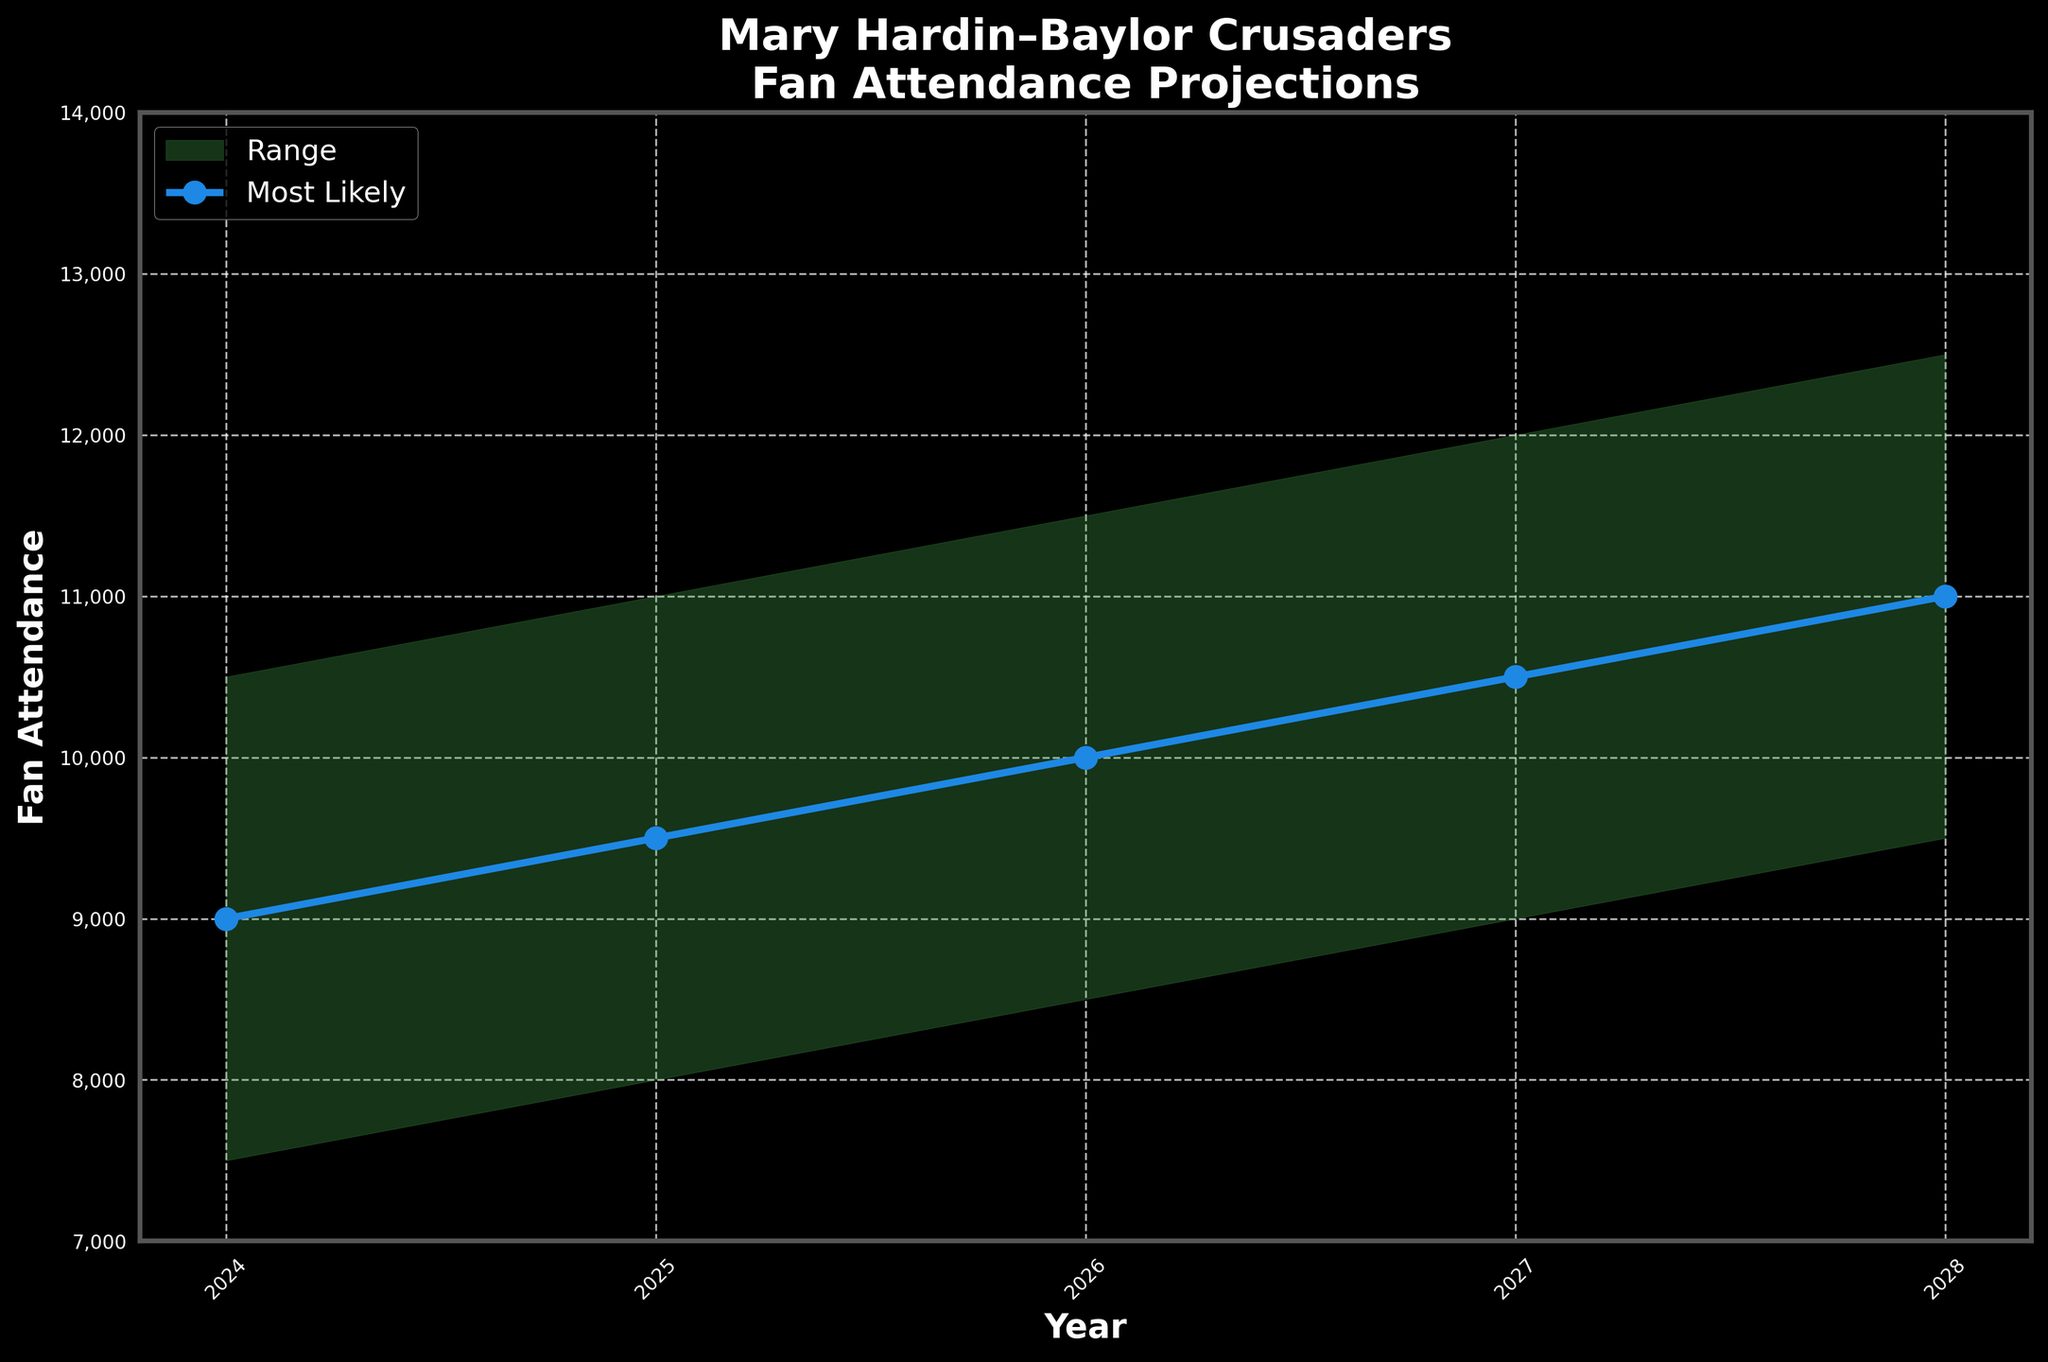What is the title of the figure? The title is prominently displayed at the top of the figure and serves as a summary of the information presented.
Answer: Mary Hardin–Baylor Crusaders Fan Attendance Projections How many years of projected fan attendance are shown in the chart? The x-axis lists all the years included in the projections. Counting them gives the total.
Answer: 5 years What is the highest projected attendance figure for the year 2025? Look at the "High" value for the year 2025 on the respective line on the chart.
Answer: 11,000 Which year has the lowest 'Most Likely' fan attendance value? Compare the 'Most Likely' values for all years.
Answer: 2024 What is the range of projected attendance for the year 2026? Subtract the 'Low' value for 2026 from the 'High' value for 2026. The difference gives the range.
Answer: 3,000 How much is the 'Most Likely' attendance projected to increase from 2024 to 2028? Subtract the 'Most Likely' value in 2024 from the 'Most Likely' value in 2028.
Answer: 2,000 In which year is the projected 'High' fan attendance first expected to reach 12,000 or more? Check the 'High' values for all years and find the first year that meets or exceeds 12,000.
Answer: 2027 What is the average 'Most Likely' fan attendance over the five years? Add the 'Most Likely' attendance values for the five years and divide by 5. Calculation: (9000 + 9500 + 10000 + 10500 + 11000) / 5 = 10,000
Answer: 10,000 What trend can you observe in the fan attendance projections over the next five years? Based on the increasing values of 'Low', 'Most Likely', and 'High' over the years, the overall trend is clearly upward.
Answer: Increasing By how much does the 'Low' fan attendance projection change from one year to the next? Calculate the differences between consecutive 'Low' values for each year. For example, 2025 - 2024: 8000 - 7500 = 500, and similarly for others (500 each year).
Answer: 500 per year 